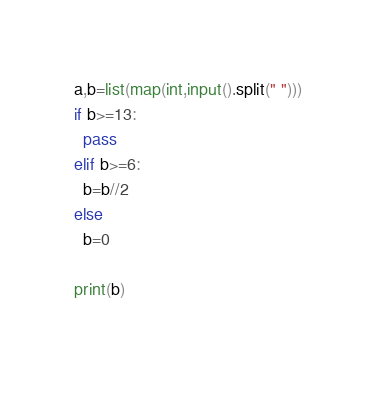Convert code to text. <code><loc_0><loc_0><loc_500><loc_500><_Python_>a,b=list(map(int,input().split(" ")))
if b>=13:
  pass
elif b>=6:
  b=b//2
else
  b=0
  
print(b)
 </code> 